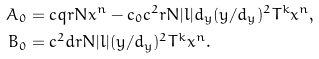<formula> <loc_0><loc_0><loc_500><loc_500>A _ { 0 } & = c q r N x ^ { n } - c _ { 0 } c ^ { 2 } r N | l | d _ { y } ( y / d _ { y } ) ^ { 2 } T ^ { k } x ^ { n } , \\ B _ { 0 } & = c ^ { 2 } d r N | l | ( y / d _ { y } ) ^ { 2 } T ^ { k } x ^ { n } .</formula> 